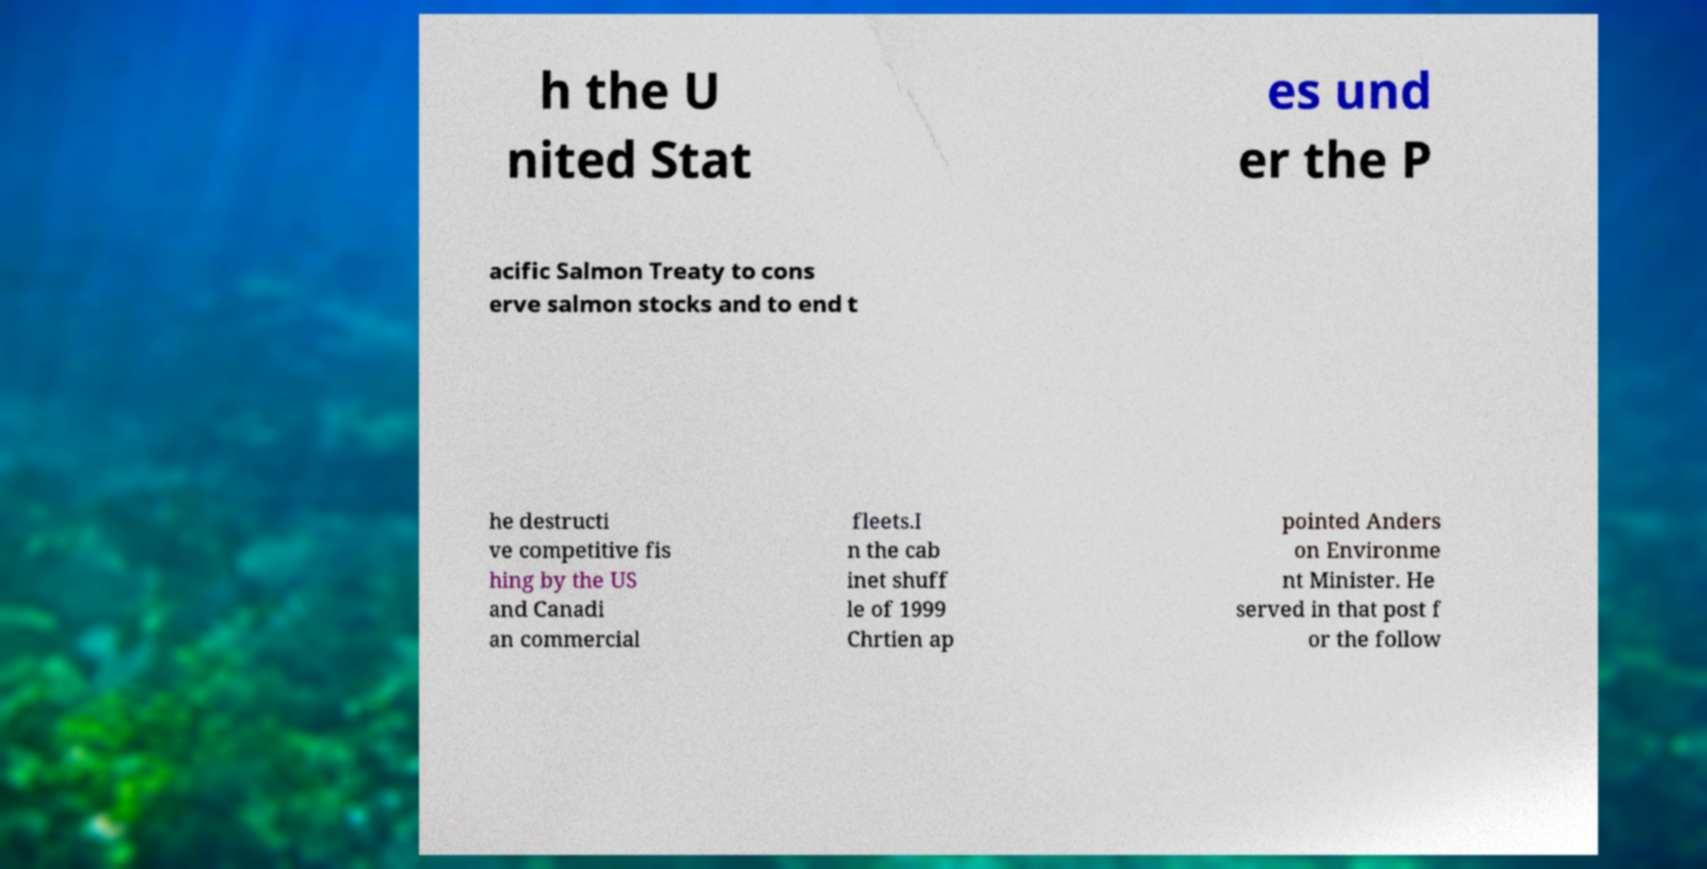Could you extract and type out the text from this image? h the U nited Stat es und er the P acific Salmon Treaty to cons erve salmon stocks and to end t he destructi ve competitive fis hing by the US and Canadi an commercial fleets.I n the cab inet shuff le of 1999 Chrtien ap pointed Anders on Environme nt Minister. He served in that post f or the follow 